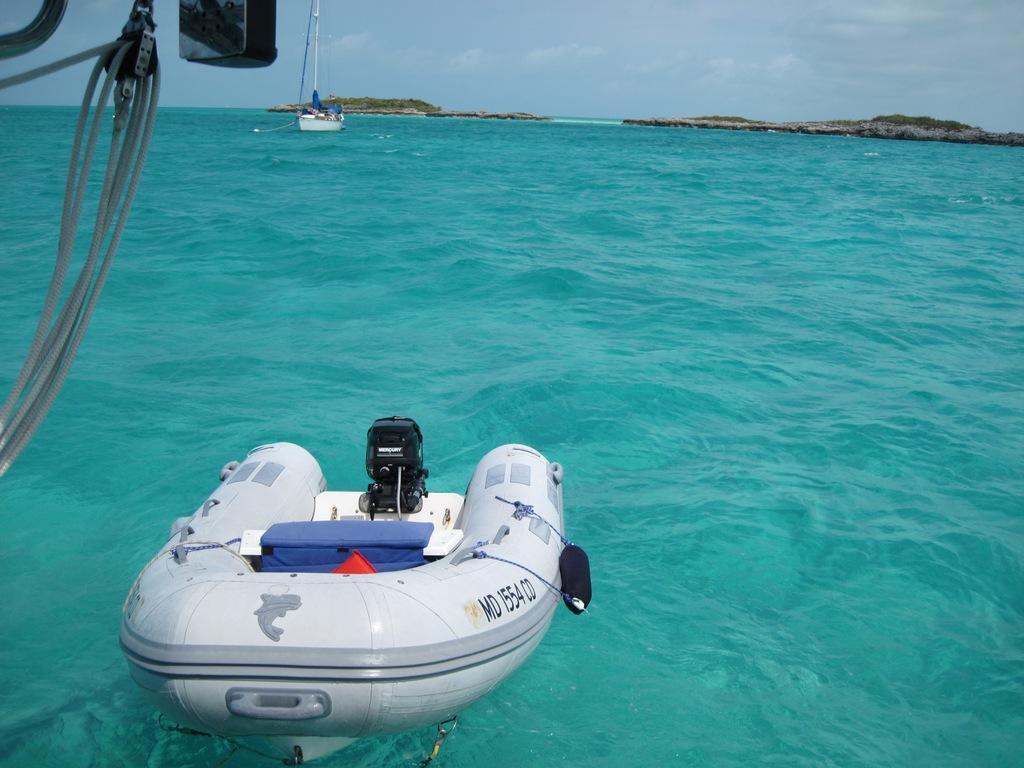In one or two sentences, can you explain what this image depicts? In this picture we can see boats, ropes, water are there. At the top of the image we can see hills, trees, clouds are present in the sky. 